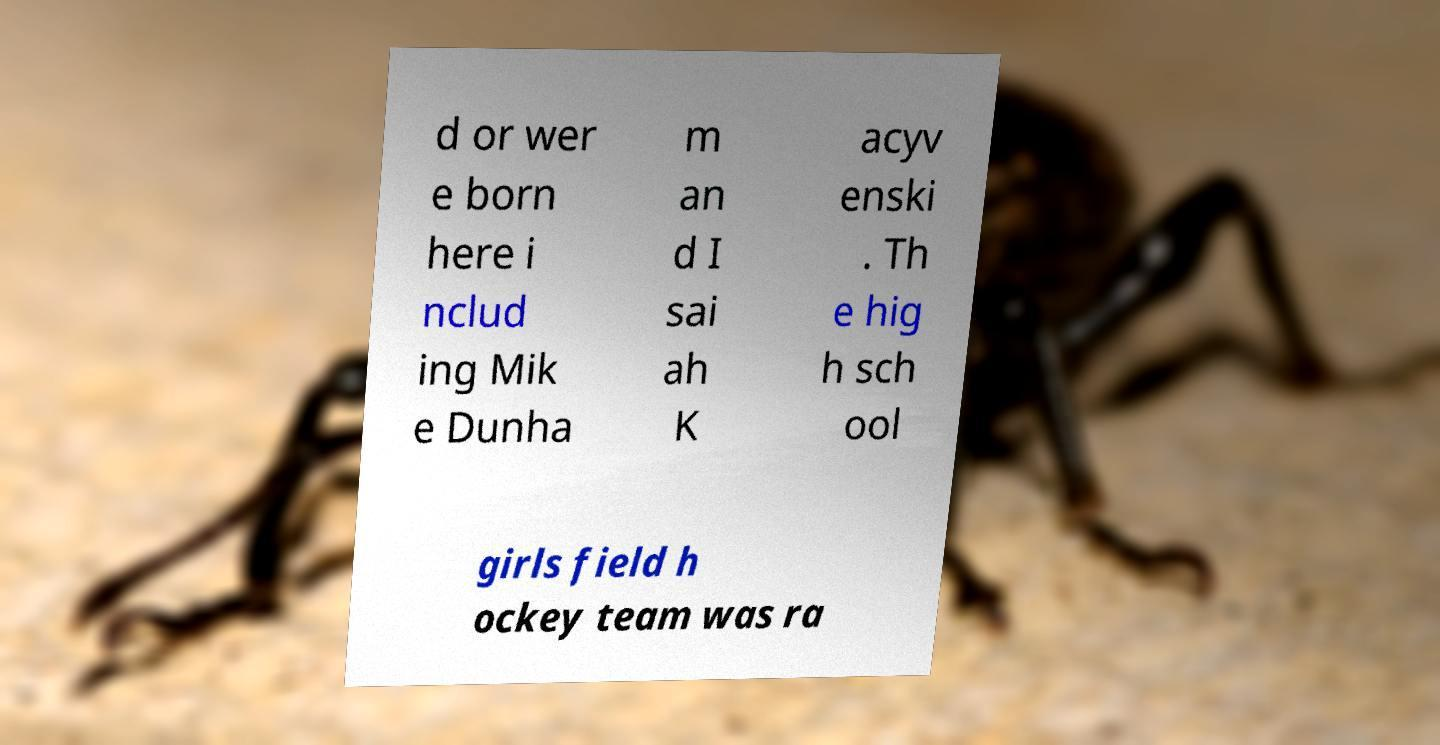Please identify and transcribe the text found in this image. d or wer e born here i nclud ing Mik e Dunha m an d I sai ah K acyv enski . Th e hig h sch ool girls field h ockey team was ra 